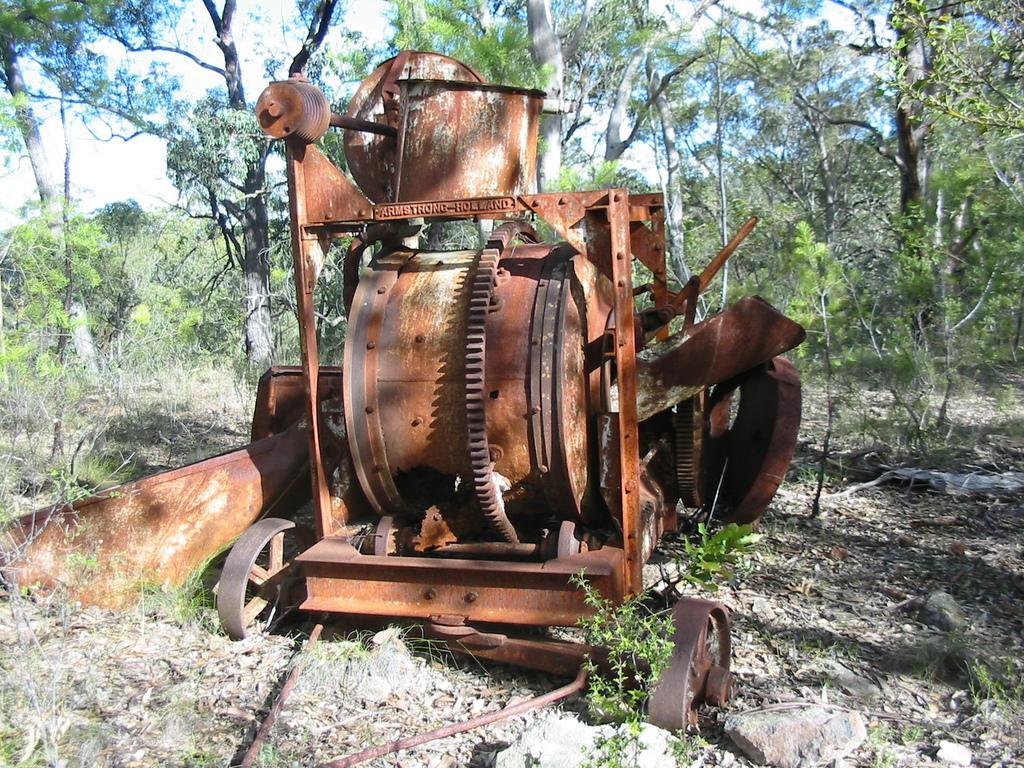How would you summarize this image in a sentence or two? In the background we can see sky and trees. Here on the ground we can see few plants and stones. Here we can see an iron vehicle with wheels. 